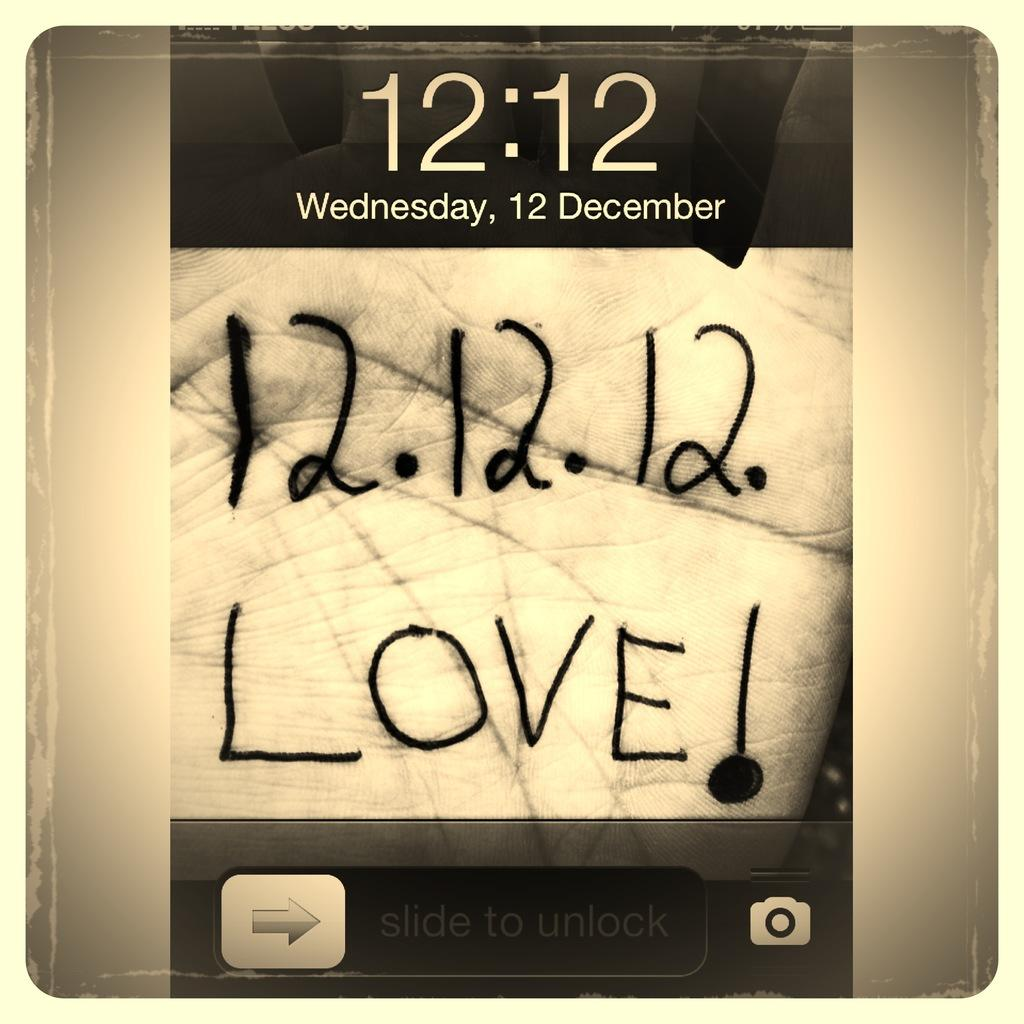<image>
Present a compact description of the photo's key features. a screen saver at 12:12 Wednesday, 12 December 